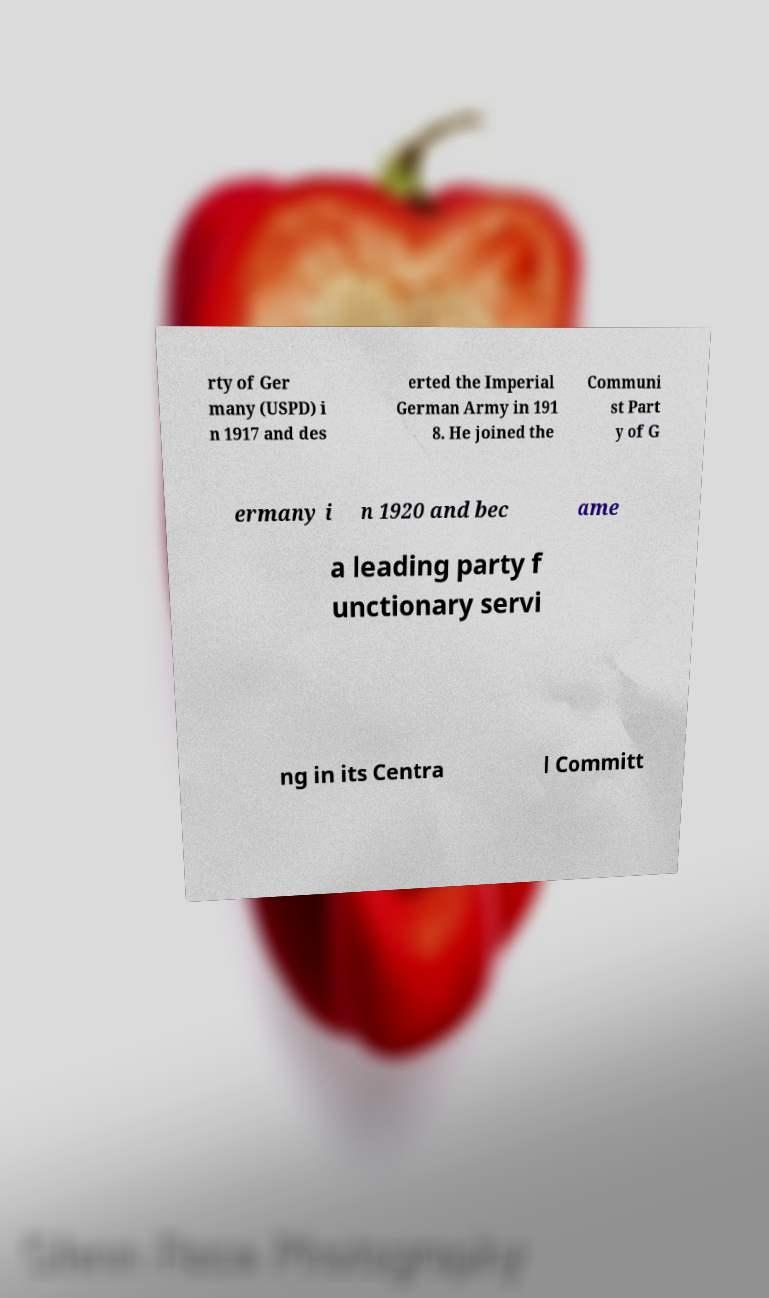For documentation purposes, I need the text within this image transcribed. Could you provide that? rty of Ger many (USPD) i n 1917 and des erted the Imperial German Army in 191 8. He joined the Communi st Part y of G ermany i n 1920 and bec ame a leading party f unctionary servi ng in its Centra l Committ 